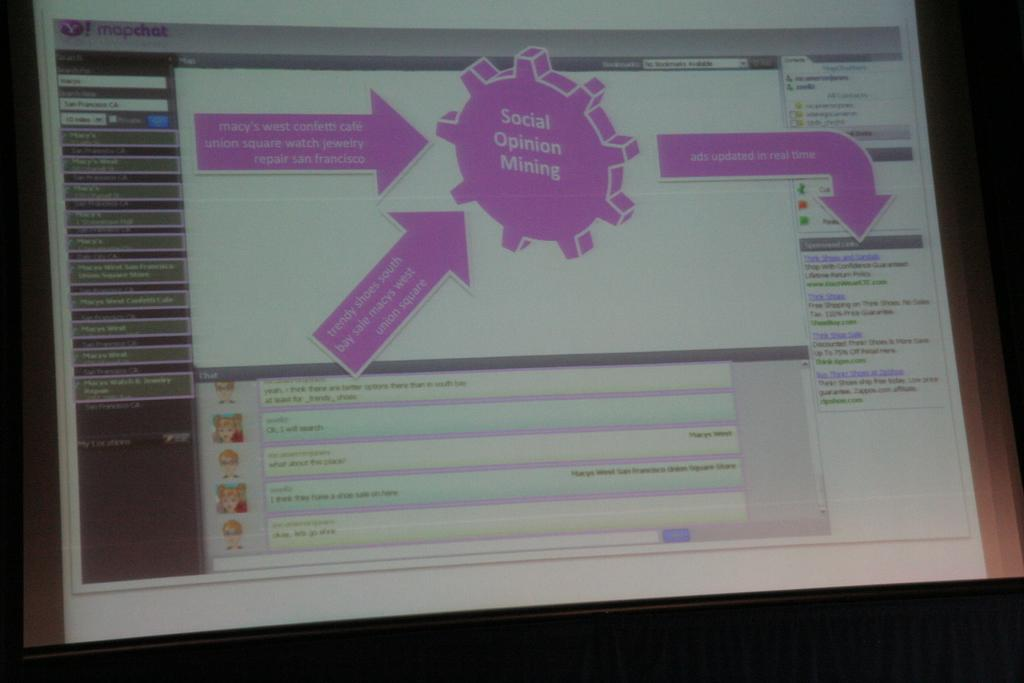<image>
Describe the image concisely. A screen is showing the website mapchat that has a social opinion mining chart. 